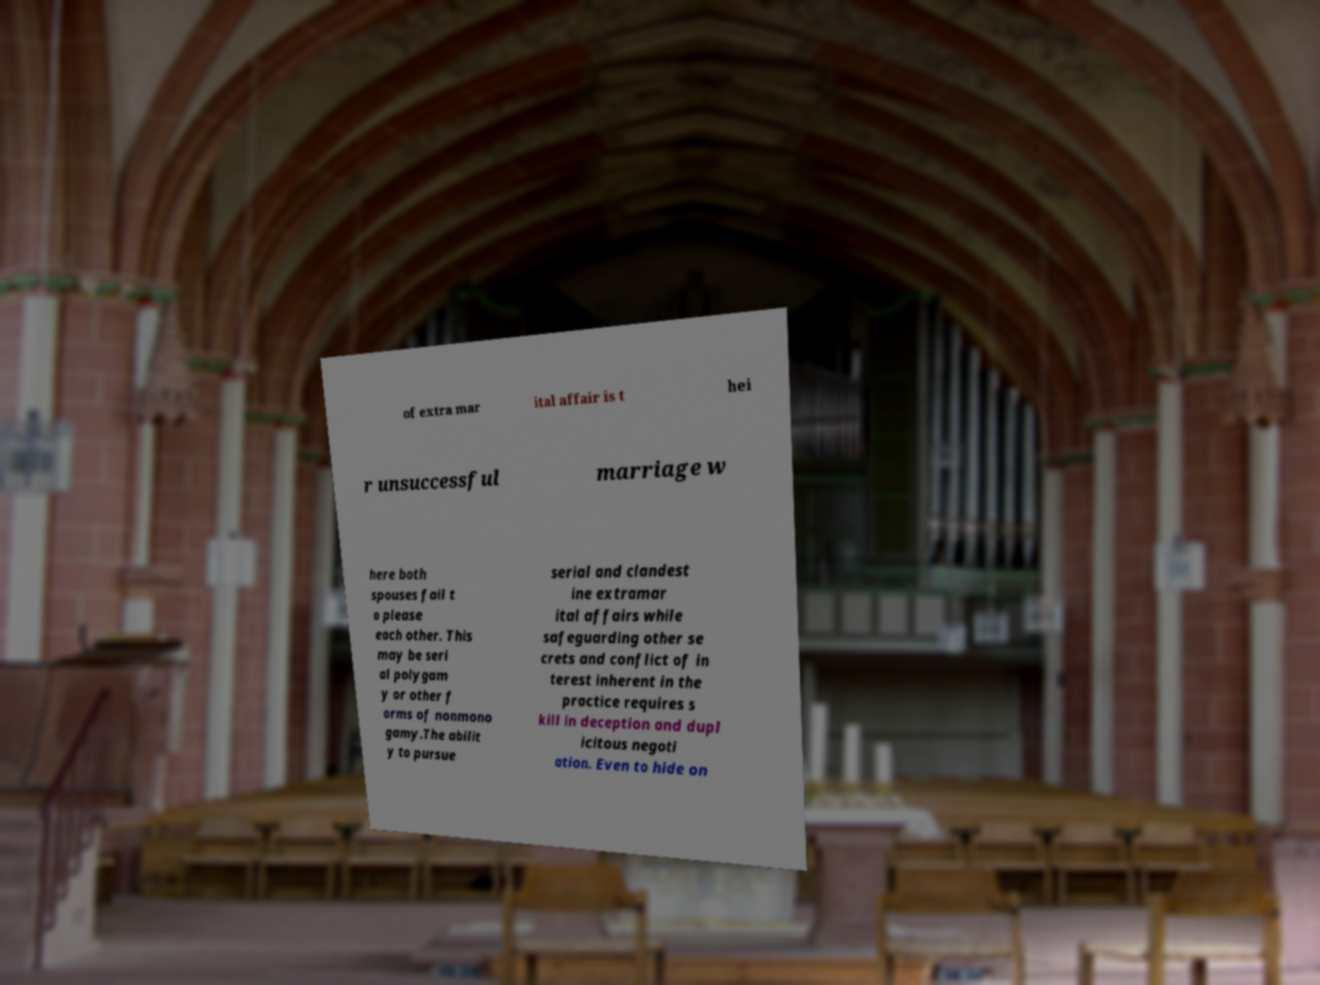Could you assist in decoding the text presented in this image and type it out clearly? of extra mar ital affair is t hei r unsuccessful marriage w here both spouses fail t o please each other. This may be seri al polygam y or other f orms of nonmono gamy.The abilit y to pursue serial and clandest ine extramar ital affairs while safeguarding other se crets and conflict of in terest inherent in the practice requires s kill in deception and dupl icitous negoti ation. Even to hide on 